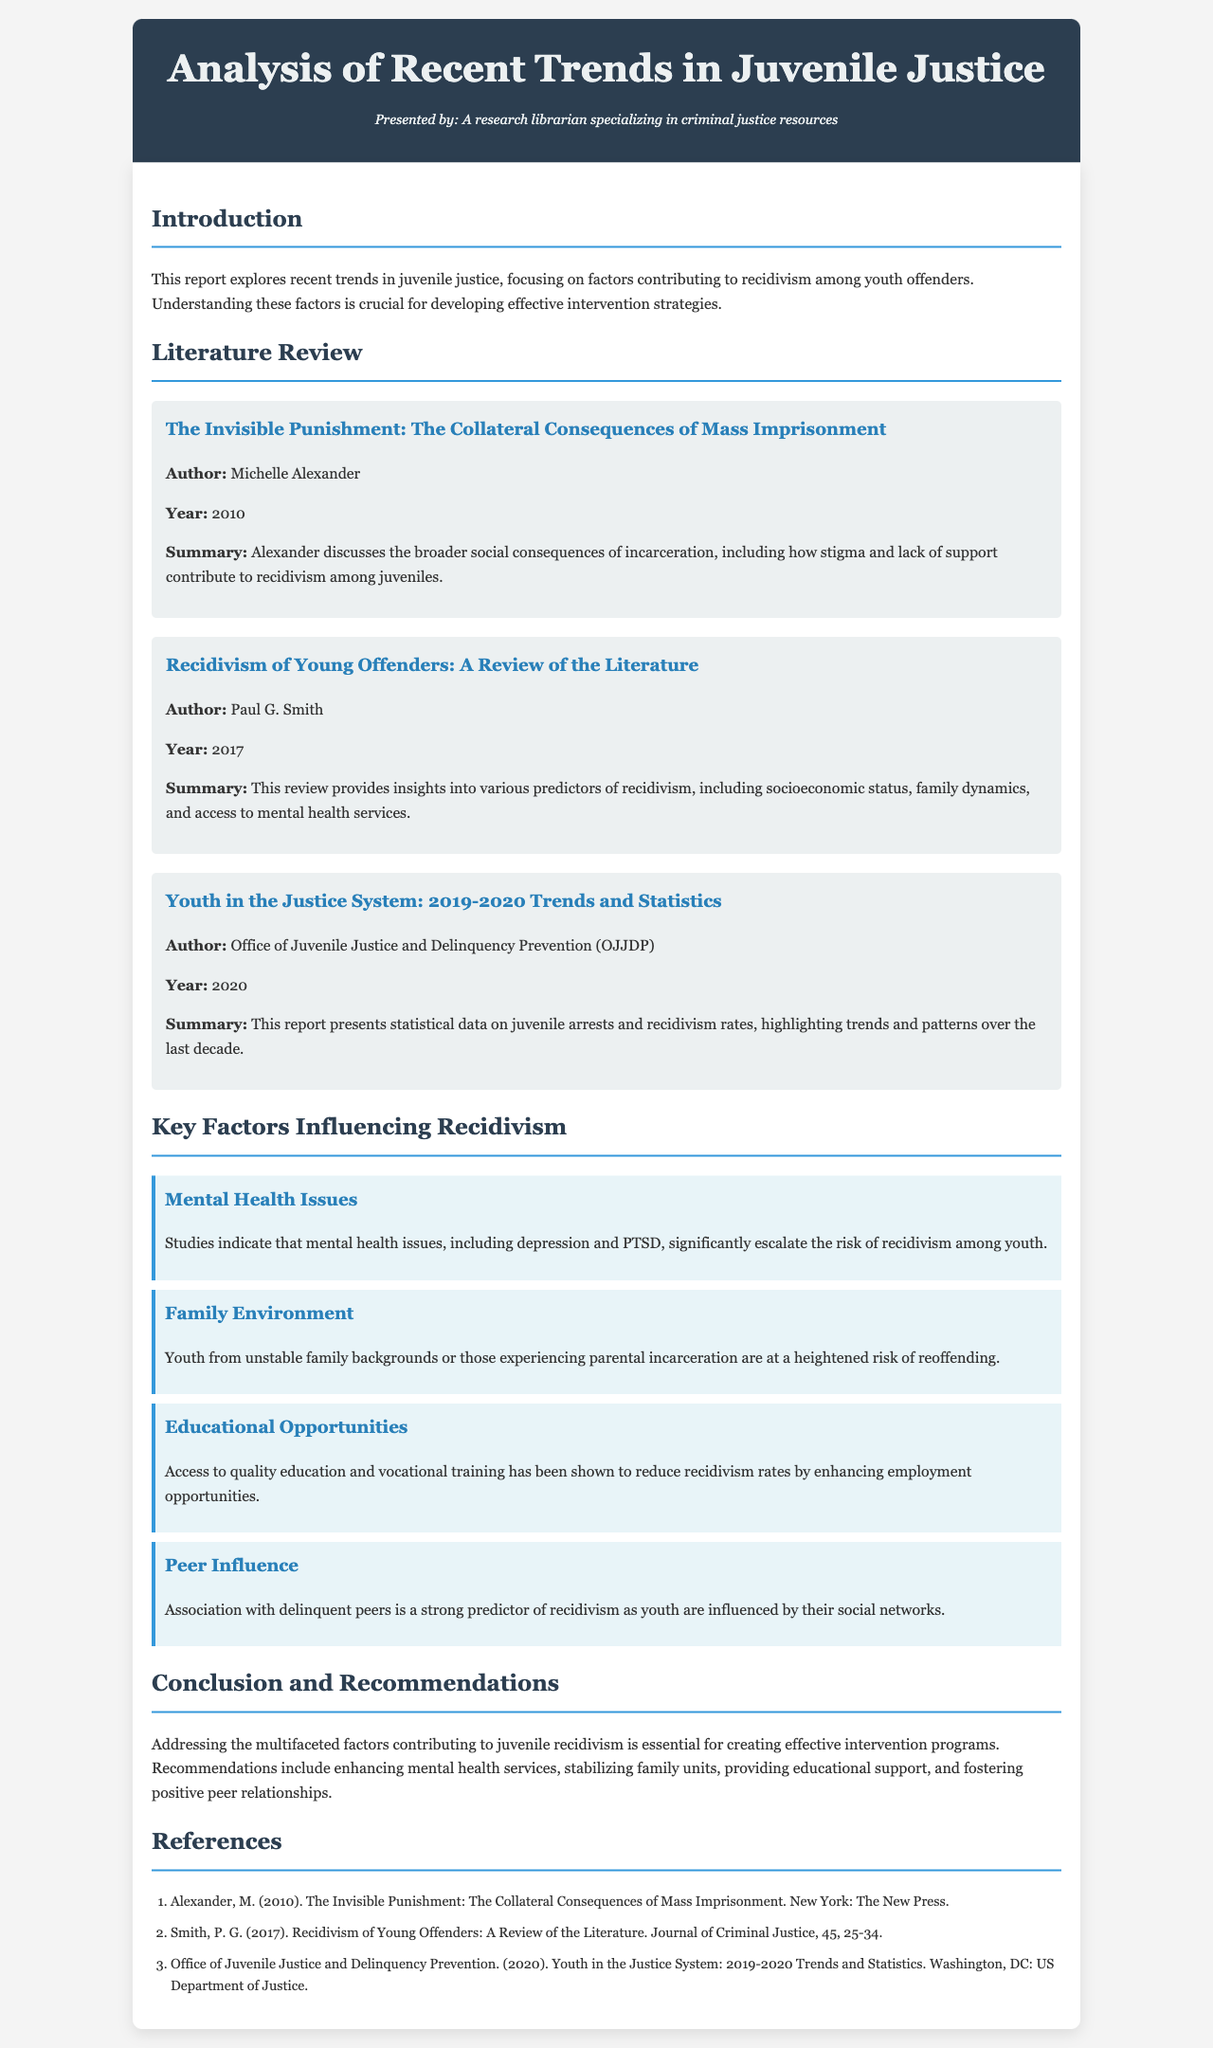what is the title of the report? The title is specifically mentioned in the header section of the document.
Answer: Analysis of Recent Trends in Juvenile Justice who is the author of "The Invisible Punishment"? The document lists the author's name in the literature review section.
Answer: Michelle Alexander what year was "Recidivism of Young Offenders: A Review of the Literature" published? The publication year is mentioned under the title in the literature review section.
Answer: 2017 how many key factors influencing recidivism are listed in the document? The document outlines these factors in the relevant section, asking for enumeration.
Answer: Four what is one of the recommendations made in the conclusion? The document specifies several recommendations in the conclusion section.
Answer: Enhancing mental health services which organization published the report titled "Youth in the Justice System: 2019-2020 Trends and Statistics"? The organization is indicated next to the report title in the literature review.
Answer: Office of Juvenile Justice and Delinquency Prevention what common issue among youth is highlighted as a key factor in recidivism? This factor is identified in the section discussing key factors influencing recidivism.
Answer: Mental Health Issues what type of document is this report? The information that defines the document type is in the introductory section.
Answer: Comprehensive Review 